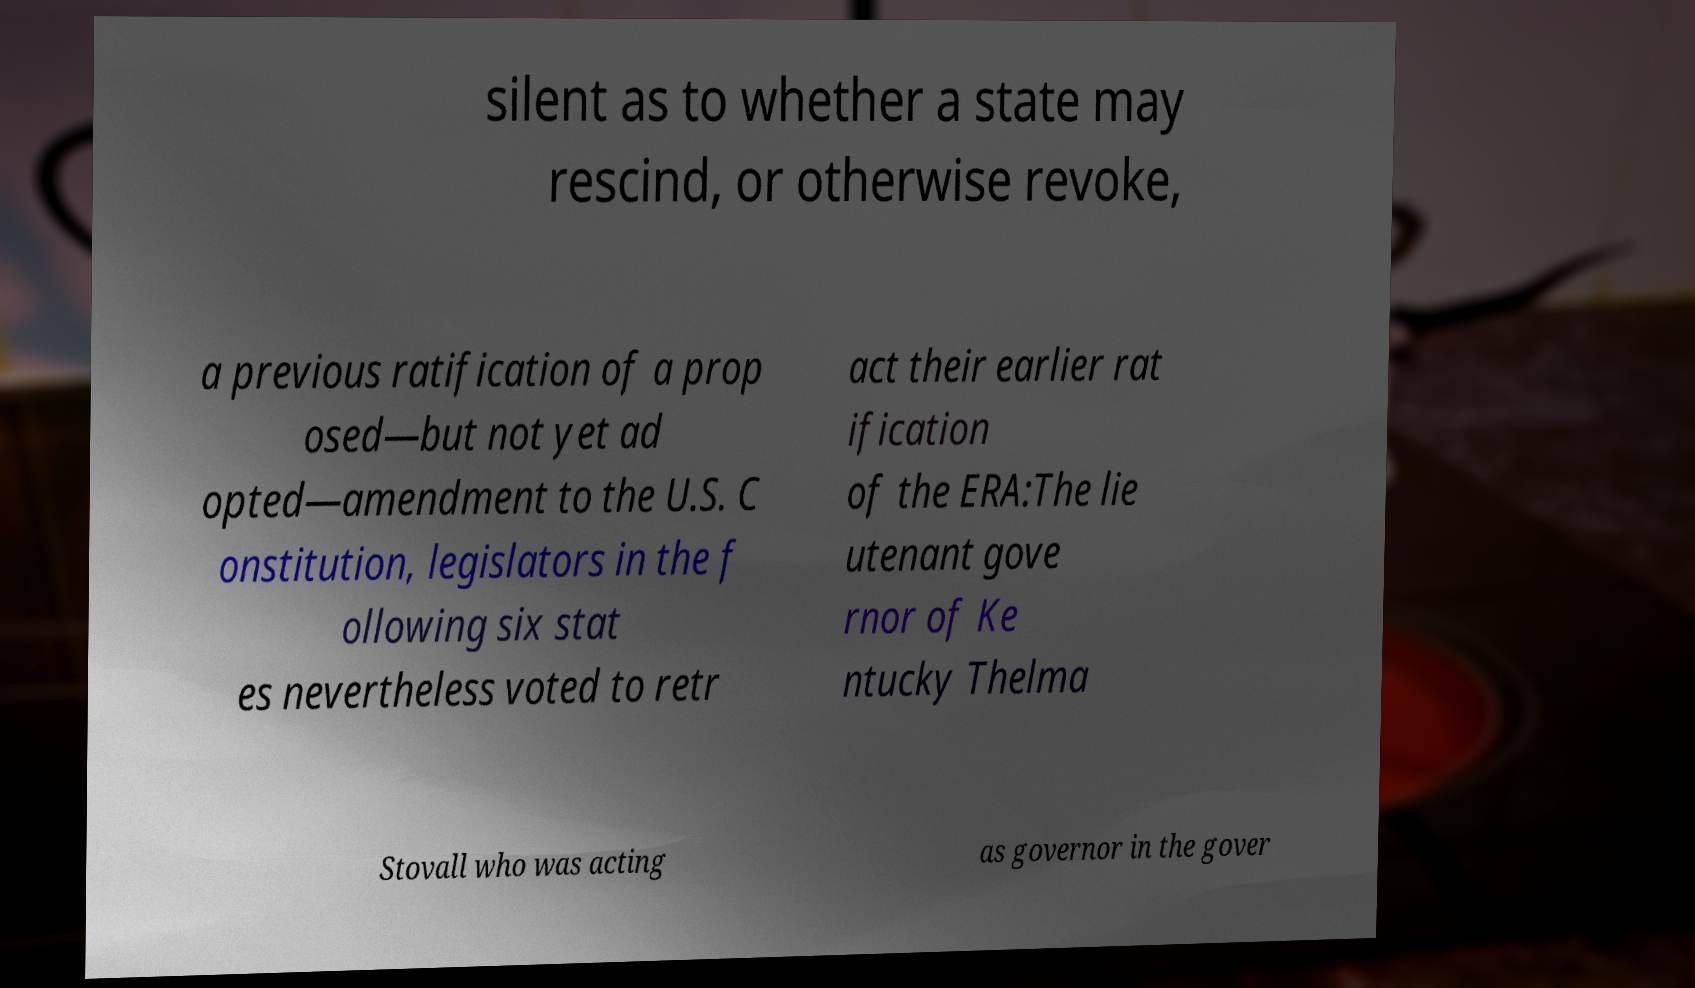Can you accurately transcribe the text from the provided image for me? silent as to whether a state may rescind, or otherwise revoke, a previous ratification of a prop osed—but not yet ad opted—amendment to the U.S. C onstitution, legislators in the f ollowing six stat es nevertheless voted to retr act their earlier rat ification of the ERA:The lie utenant gove rnor of Ke ntucky Thelma Stovall who was acting as governor in the gover 